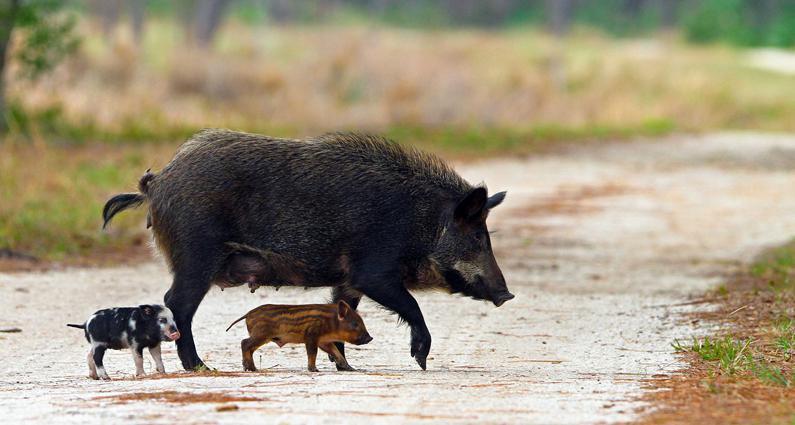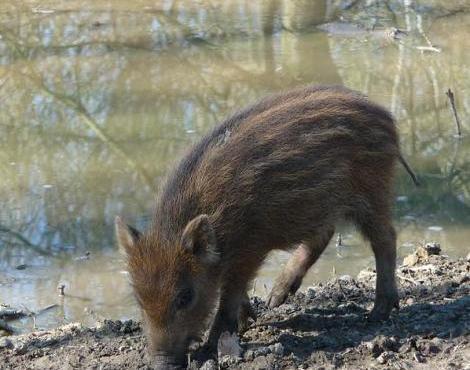The first image is the image on the left, the second image is the image on the right. Assess this claim about the two images: "There are at least two baby boars in one of the images.". Correct or not? Answer yes or no. Yes. 